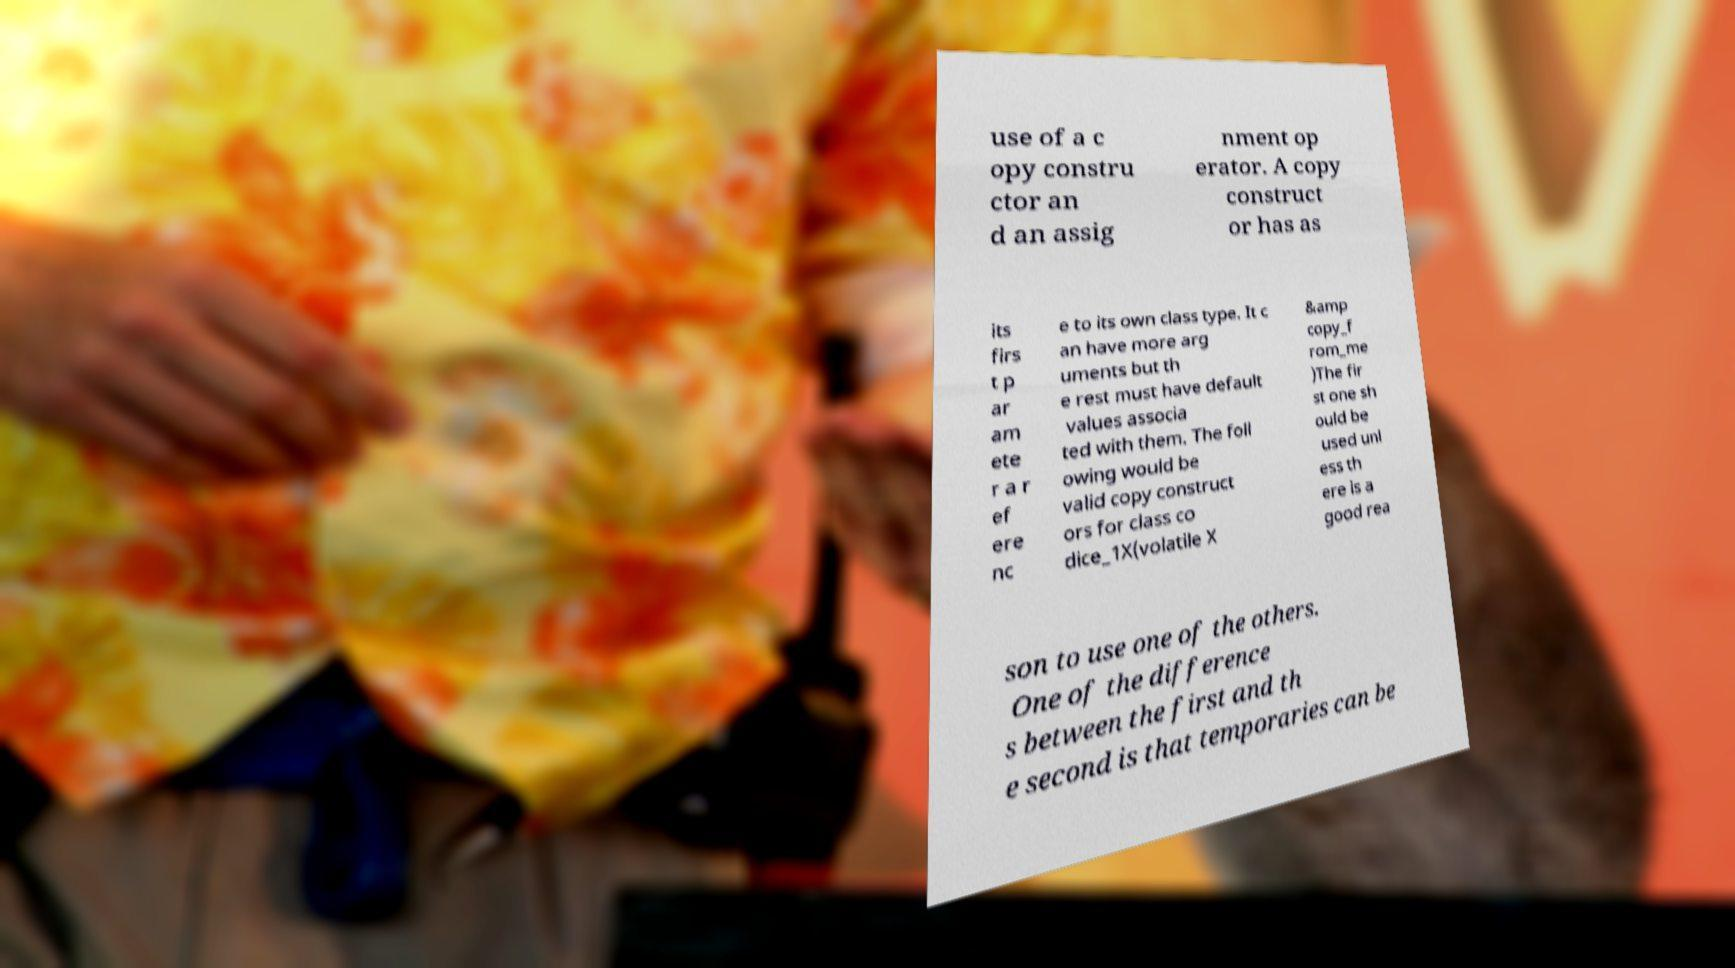I need the written content from this picture converted into text. Can you do that? use of a c opy constru ctor an d an assig nment op erator. A copy construct or has as its firs t p ar am ete r a r ef ere nc e to its own class type. It c an have more arg uments but th e rest must have default values associa ted with them. The foll owing would be valid copy construct ors for class co dice_1X(volatile X &amp copy_f rom_me )The fir st one sh ould be used unl ess th ere is a good rea son to use one of the others. One of the difference s between the first and th e second is that temporaries can be 